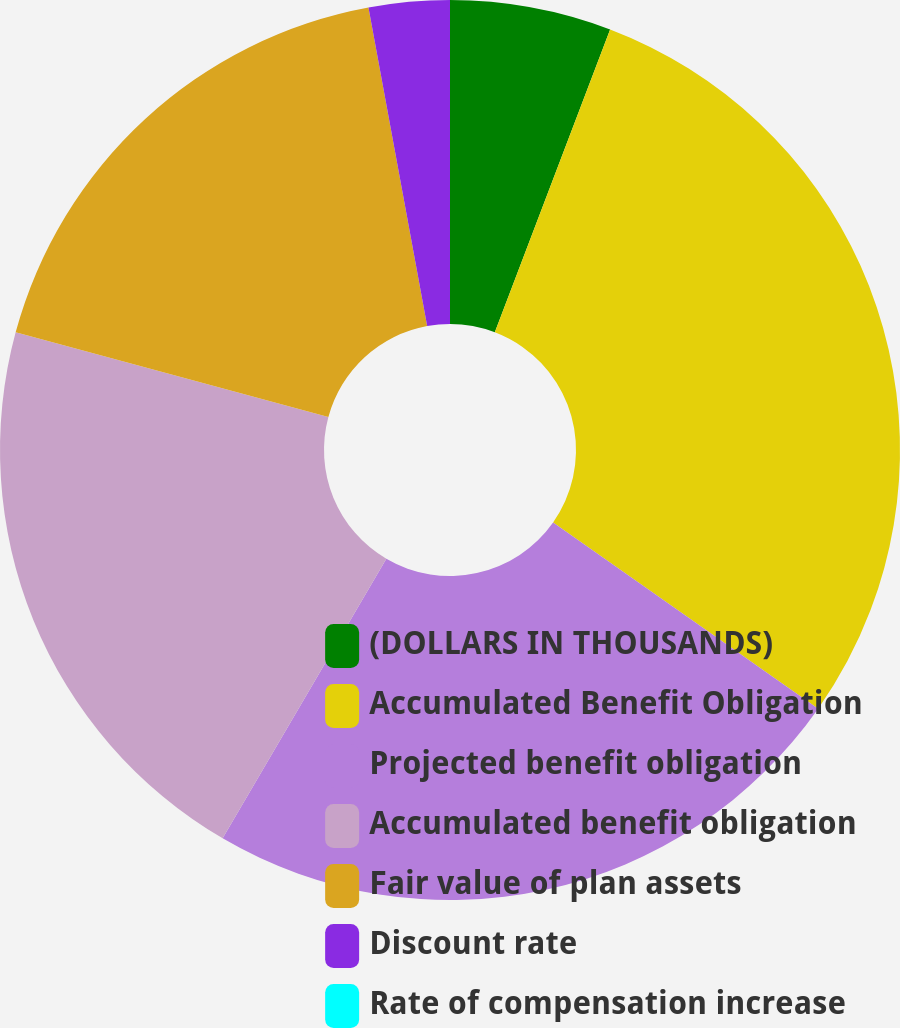Convert chart to OTSL. <chart><loc_0><loc_0><loc_500><loc_500><pie_chart><fcel>(DOLLARS IN THOUSANDS)<fcel>Accumulated Benefit Obligation<fcel>Projected benefit obligation<fcel>Accumulated benefit obligation<fcel>Fair value of plan assets<fcel>Discount rate<fcel>Rate of compensation increase<nl><fcel>5.79%<fcel>28.96%<fcel>23.68%<fcel>20.78%<fcel>17.89%<fcel>2.9%<fcel>0.0%<nl></chart> 